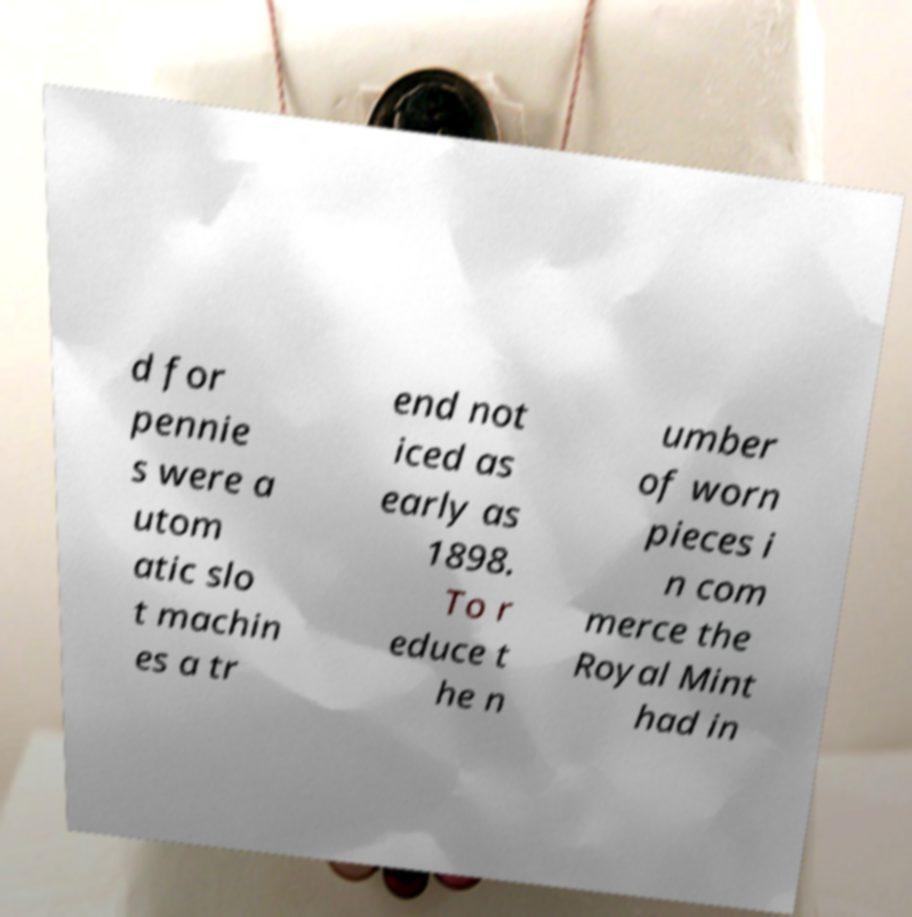Please read and relay the text visible in this image. What does it say? d for pennie s were a utom atic slo t machin es a tr end not iced as early as 1898. To r educe t he n umber of worn pieces i n com merce the Royal Mint had in 